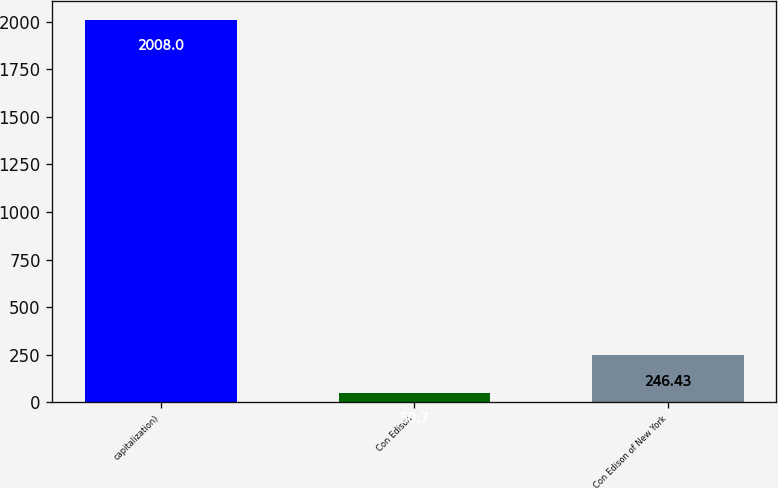Convert chart. <chart><loc_0><loc_0><loc_500><loc_500><bar_chart><fcel>capitalization)<fcel>Con Edison<fcel>Con Edison of New York<nl><fcel>2008<fcel>50.7<fcel>246.43<nl></chart> 